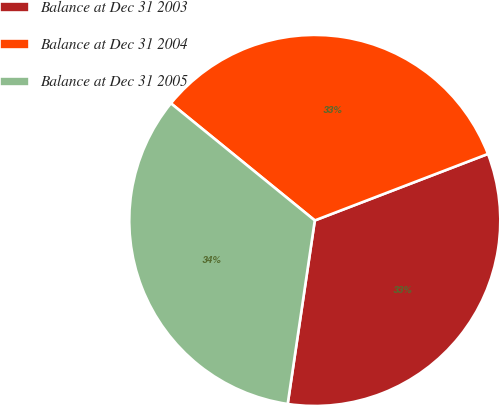Convert chart to OTSL. <chart><loc_0><loc_0><loc_500><loc_500><pie_chart><fcel>Balance at Dec 31 2003<fcel>Balance at Dec 31 2004<fcel>Balance at Dec 31 2005<nl><fcel>33.17%<fcel>33.29%<fcel>33.54%<nl></chart> 